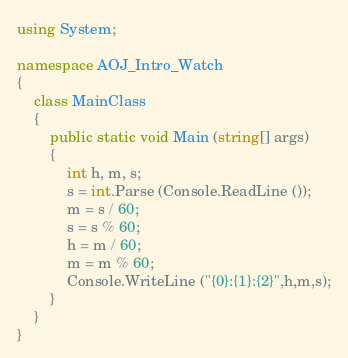Convert code to text. <code><loc_0><loc_0><loc_500><loc_500><_C#_>using System;

namespace AOJ_Intro_Watch
{
	class MainClass
	{
		public static void Main (string[] args)
		{
			int h, m, s;
			s = int.Parse (Console.ReadLine ());
			m = s / 60;
			s = s % 60;
			h = m / 60;
			m = m % 60;
			Console.WriteLine ("{0}:{1}:{2}",h,m,s);
		}
	}
}</code> 